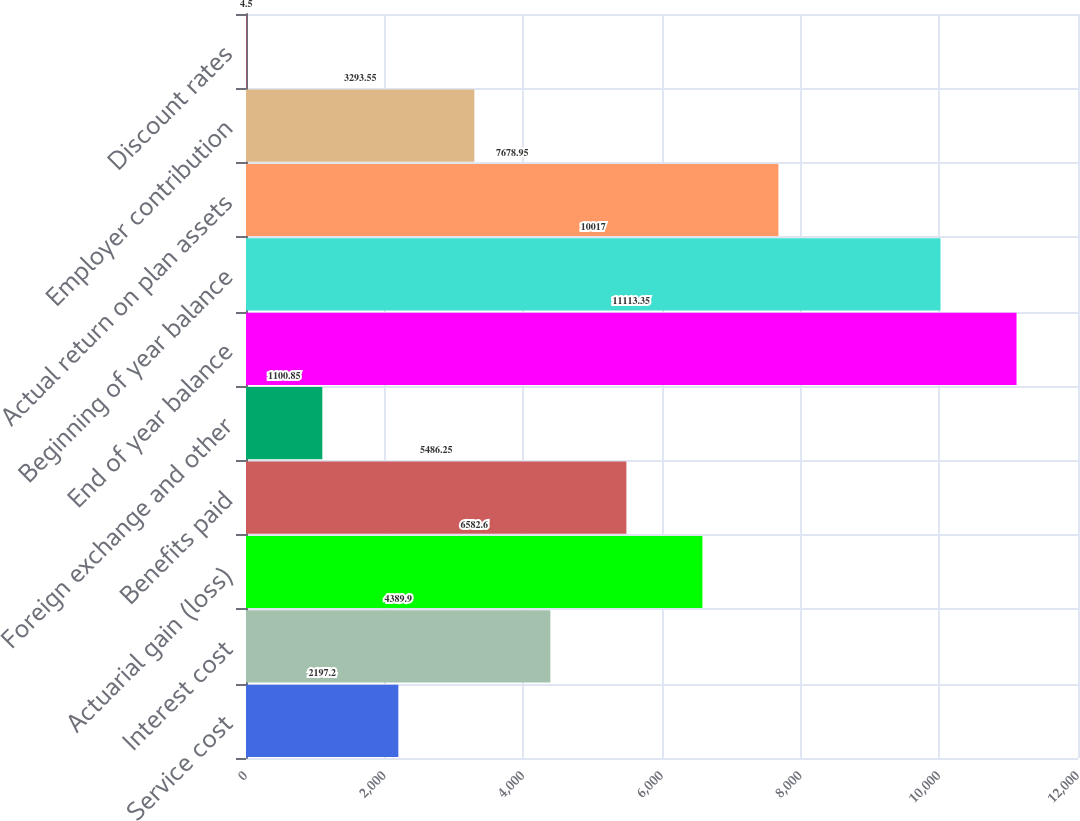Convert chart to OTSL. <chart><loc_0><loc_0><loc_500><loc_500><bar_chart><fcel>Service cost<fcel>Interest cost<fcel>Actuarial gain (loss)<fcel>Benefits paid<fcel>Foreign exchange and other<fcel>End of year balance<fcel>Beginning of year balance<fcel>Actual return on plan assets<fcel>Employer contribution<fcel>Discount rates<nl><fcel>2197.2<fcel>4389.9<fcel>6582.6<fcel>5486.25<fcel>1100.85<fcel>11113.4<fcel>10017<fcel>7678.95<fcel>3293.55<fcel>4.5<nl></chart> 